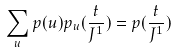<formula> <loc_0><loc_0><loc_500><loc_500>\sum _ { u } p ( u ) p _ { u } ( \frac { t } { J ^ { 1 } } ) = p ( \frac { t } { J ^ { 1 } } )</formula> 